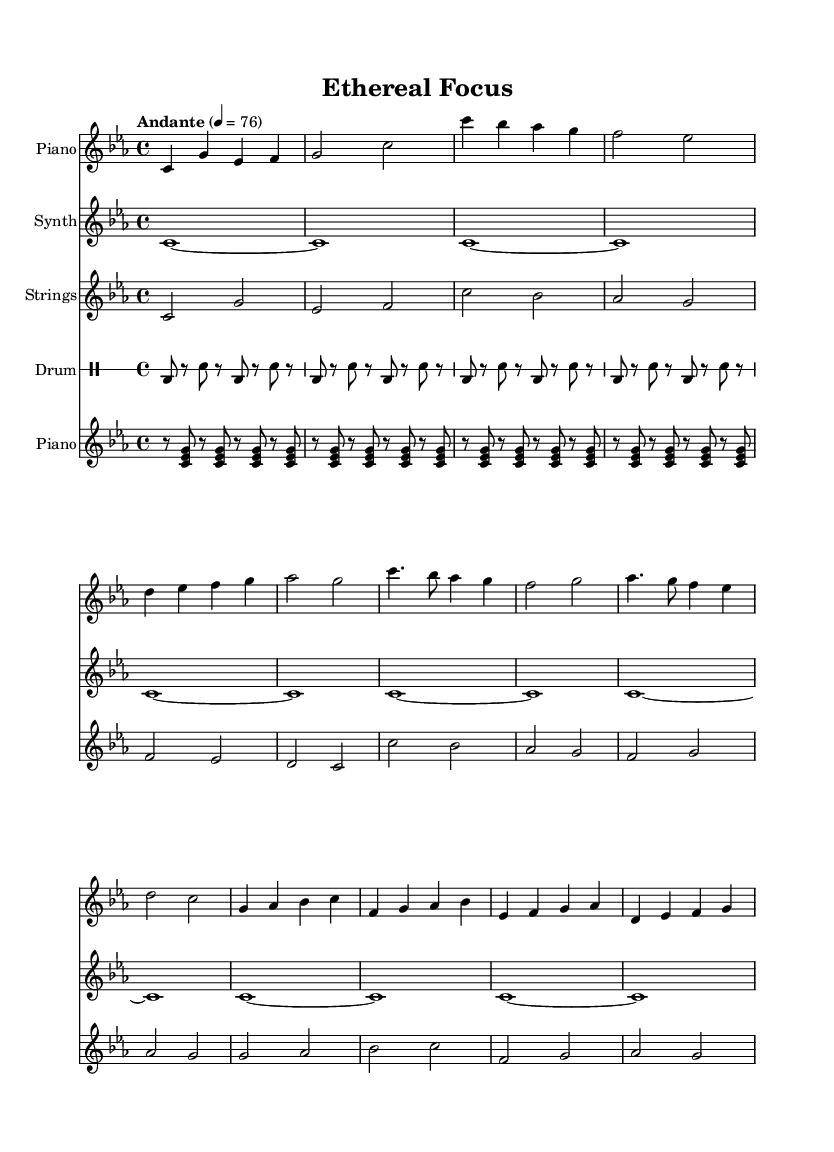What is the key signature of this music? The key signature is C minor, which has three flats (B flat, E flat, and A flat). It can be determined by looking at the key signature at the beginning of the sheet music.
Answer: C minor What is the time signature of this music? The time signature is found at the beginning of the sheet music and it shows that there are four beats in each measure, typical for 4/4 time.
Answer: 4/4 What is the tempo marking of this piece? The tempo marking indicates the speed of the music; "Andante" suggests a moderately slow pace. It is usually located at the beginning of the score.
Answer: Andante How many sections are there in this piece? By analyzing the structure provided in the sheet music, there are distinct parts labeled as Intro, Verse, Chorus, and Bridge, totaling four sections.
Answer: Four What instruments are used in the composition? The sheet music indicates the inclusion of Piano, Synth, Strings, and Drum, as seen in the instrument names provided for each staff.
Answer: Piano, Synth, Strings, Drum What is the primary musical style of this piece? This piece combines elements of ambient electronic music with classical music, typical of a fusion style that is designed for focused work sessions, as evidenced by the instrumentation and harmonies.
Answer: Fusion How does the drum pattern contribute to the overall ambiance of the piece? The basic drum pattern underlines rhythmic stability without being intrusive, allowing the ambient qualities of the synthesizer and strings to maintain prominence, creating an atmospheric background essential for focused work.
Answer: Supports ambiance 